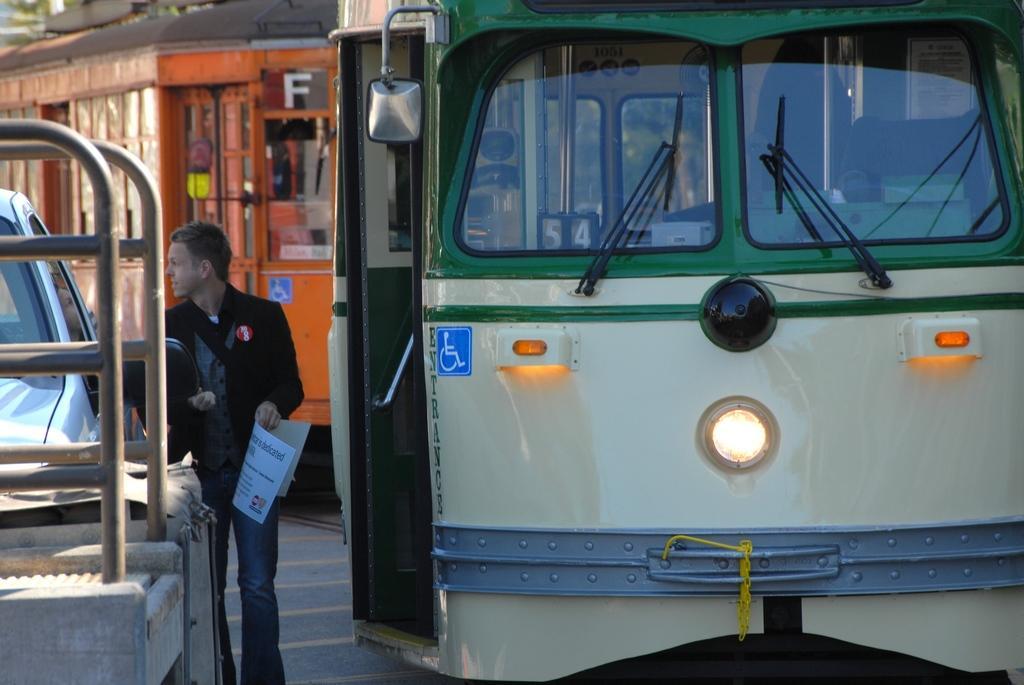Can you describe this image briefly? In this picture there are some vehicles where their is a bus at the front with green color windows and also with headlights which are blowing and here is another bus which is orange in color and here is a person who is holding a paper in his right hand and he is also having some batch and here is a car which is white in color and the person is looking towards his right. 